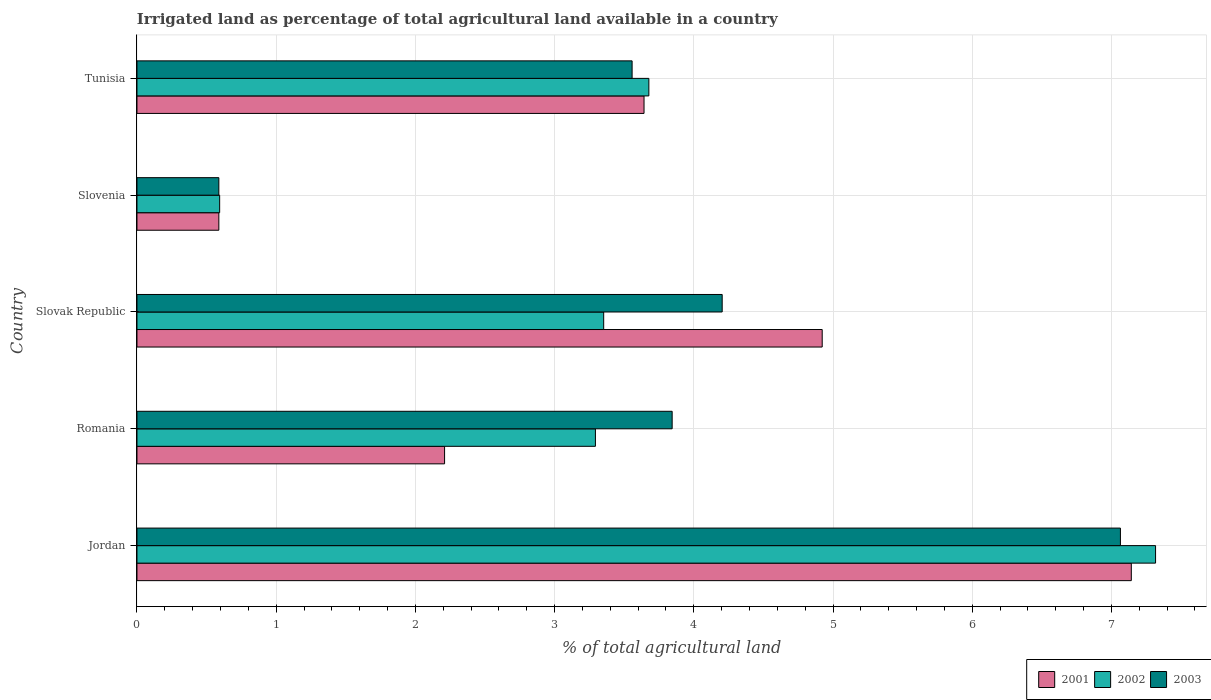Are the number of bars per tick equal to the number of legend labels?
Your answer should be compact. Yes. How many bars are there on the 5th tick from the bottom?
Provide a succinct answer. 3. What is the label of the 4th group of bars from the top?
Ensure brevity in your answer.  Romania. What is the percentage of irrigated land in 2002 in Jordan?
Provide a short and direct response. 7.32. Across all countries, what is the maximum percentage of irrigated land in 2002?
Offer a terse response. 7.32. Across all countries, what is the minimum percentage of irrigated land in 2003?
Keep it short and to the point. 0.59. In which country was the percentage of irrigated land in 2002 maximum?
Provide a succinct answer. Jordan. In which country was the percentage of irrigated land in 2003 minimum?
Keep it short and to the point. Slovenia. What is the total percentage of irrigated land in 2003 in the graph?
Your response must be concise. 19.26. What is the difference between the percentage of irrigated land in 2003 in Jordan and that in Slovenia?
Provide a short and direct response. 6.48. What is the difference between the percentage of irrigated land in 2002 in Romania and the percentage of irrigated land in 2001 in Tunisia?
Provide a succinct answer. -0.35. What is the average percentage of irrigated land in 2003 per country?
Your answer should be very brief. 3.85. What is the ratio of the percentage of irrigated land in 2003 in Jordan to that in Romania?
Make the answer very short. 1.84. Is the percentage of irrigated land in 2002 in Slovenia less than that in Tunisia?
Offer a very short reply. Yes. Is the difference between the percentage of irrigated land in 2001 in Slovak Republic and Tunisia greater than the difference between the percentage of irrigated land in 2003 in Slovak Republic and Tunisia?
Ensure brevity in your answer.  Yes. What is the difference between the highest and the second highest percentage of irrigated land in 2001?
Your response must be concise. 2.22. What is the difference between the highest and the lowest percentage of irrigated land in 2001?
Provide a succinct answer. 6.55. What does the 3rd bar from the top in Romania represents?
Keep it short and to the point. 2001. Is it the case that in every country, the sum of the percentage of irrigated land in 2003 and percentage of irrigated land in 2002 is greater than the percentage of irrigated land in 2001?
Keep it short and to the point. Yes. Are all the bars in the graph horizontal?
Your answer should be very brief. Yes. How many countries are there in the graph?
Ensure brevity in your answer.  5. What is the difference between two consecutive major ticks on the X-axis?
Make the answer very short. 1. Does the graph contain grids?
Give a very brief answer. Yes. Where does the legend appear in the graph?
Your answer should be very brief. Bottom right. How are the legend labels stacked?
Keep it short and to the point. Horizontal. What is the title of the graph?
Make the answer very short. Irrigated land as percentage of total agricultural land available in a country. What is the label or title of the X-axis?
Keep it short and to the point. % of total agricultural land. What is the label or title of the Y-axis?
Ensure brevity in your answer.  Country. What is the % of total agricultural land in 2001 in Jordan?
Your answer should be very brief. 7.14. What is the % of total agricultural land in 2002 in Jordan?
Make the answer very short. 7.32. What is the % of total agricultural land in 2003 in Jordan?
Provide a short and direct response. 7.06. What is the % of total agricultural land of 2001 in Romania?
Your answer should be very brief. 2.21. What is the % of total agricultural land in 2002 in Romania?
Your response must be concise. 3.29. What is the % of total agricultural land of 2003 in Romania?
Ensure brevity in your answer.  3.84. What is the % of total agricultural land in 2001 in Slovak Republic?
Provide a short and direct response. 4.92. What is the % of total agricultural land in 2002 in Slovak Republic?
Your answer should be compact. 3.35. What is the % of total agricultural land of 2003 in Slovak Republic?
Your answer should be very brief. 4.2. What is the % of total agricultural land of 2001 in Slovenia?
Give a very brief answer. 0.59. What is the % of total agricultural land of 2002 in Slovenia?
Your response must be concise. 0.59. What is the % of total agricultural land in 2003 in Slovenia?
Your answer should be compact. 0.59. What is the % of total agricultural land in 2001 in Tunisia?
Your answer should be compact. 3.64. What is the % of total agricultural land of 2002 in Tunisia?
Offer a terse response. 3.68. What is the % of total agricultural land of 2003 in Tunisia?
Your answer should be compact. 3.56. Across all countries, what is the maximum % of total agricultural land of 2001?
Provide a short and direct response. 7.14. Across all countries, what is the maximum % of total agricultural land in 2002?
Your answer should be compact. 7.32. Across all countries, what is the maximum % of total agricultural land of 2003?
Offer a terse response. 7.06. Across all countries, what is the minimum % of total agricultural land of 2001?
Your answer should be compact. 0.59. Across all countries, what is the minimum % of total agricultural land in 2002?
Make the answer very short. 0.59. Across all countries, what is the minimum % of total agricultural land of 2003?
Provide a succinct answer. 0.59. What is the total % of total agricultural land of 2001 in the graph?
Your answer should be compact. 18.51. What is the total % of total agricultural land in 2002 in the graph?
Give a very brief answer. 18.23. What is the total % of total agricultural land in 2003 in the graph?
Provide a short and direct response. 19.26. What is the difference between the % of total agricultural land in 2001 in Jordan and that in Romania?
Give a very brief answer. 4.93. What is the difference between the % of total agricultural land in 2002 in Jordan and that in Romania?
Provide a short and direct response. 4.02. What is the difference between the % of total agricultural land in 2003 in Jordan and that in Romania?
Your response must be concise. 3.22. What is the difference between the % of total agricultural land in 2001 in Jordan and that in Slovak Republic?
Keep it short and to the point. 2.22. What is the difference between the % of total agricultural land in 2002 in Jordan and that in Slovak Republic?
Give a very brief answer. 3.96. What is the difference between the % of total agricultural land in 2003 in Jordan and that in Slovak Republic?
Your answer should be compact. 2.86. What is the difference between the % of total agricultural land of 2001 in Jordan and that in Slovenia?
Ensure brevity in your answer.  6.55. What is the difference between the % of total agricultural land in 2002 in Jordan and that in Slovenia?
Your response must be concise. 6.72. What is the difference between the % of total agricultural land of 2003 in Jordan and that in Slovenia?
Keep it short and to the point. 6.48. What is the difference between the % of total agricultural land of 2001 in Jordan and that in Tunisia?
Make the answer very short. 3.5. What is the difference between the % of total agricultural land in 2002 in Jordan and that in Tunisia?
Keep it short and to the point. 3.64. What is the difference between the % of total agricultural land of 2003 in Jordan and that in Tunisia?
Provide a succinct answer. 3.51. What is the difference between the % of total agricultural land in 2001 in Romania and that in Slovak Republic?
Ensure brevity in your answer.  -2.71. What is the difference between the % of total agricultural land of 2002 in Romania and that in Slovak Republic?
Ensure brevity in your answer.  -0.06. What is the difference between the % of total agricultural land in 2003 in Romania and that in Slovak Republic?
Your response must be concise. -0.36. What is the difference between the % of total agricultural land of 2001 in Romania and that in Slovenia?
Offer a terse response. 1.62. What is the difference between the % of total agricultural land of 2002 in Romania and that in Slovenia?
Give a very brief answer. 2.7. What is the difference between the % of total agricultural land of 2003 in Romania and that in Slovenia?
Provide a short and direct response. 3.26. What is the difference between the % of total agricultural land in 2001 in Romania and that in Tunisia?
Keep it short and to the point. -1.43. What is the difference between the % of total agricultural land of 2002 in Romania and that in Tunisia?
Provide a short and direct response. -0.38. What is the difference between the % of total agricultural land in 2003 in Romania and that in Tunisia?
Offer a terse response. 0.29. What is the difference between the % of total agricultural land of 2001 in Slovak Republic and that in Slovenia?
Your response must be concise. 4.33. What is the difference between the % of total agricultural land in 2002 in Slovak Republic and that in Slovenia?
Offer a very short reply. 2.76. What is the difference between the % of total agricultural land in 2003 in Slovak Republic and that in Slovenia?
Provide a short and direct response. 3.62. What is the difference between the % of total agricultural land of 2001 in Slovak Republic and that in Tunisia?
Your response must be concise. 1.28. What is the difference between the % of total agricultural land in 2002 in Slovak Republic and that in Tunisia?
Offer a terse response. -0.32. What is the difference between the % of total agricultural land of 2003 in Slovak Republic and that in Tunisia?
Your answer should be very brief. 0.65. What is the difference between the % of total agricultural land in 2001 in Slovenia and that in Tunisia?
Make the answer very short. -3.05. What is the difference between the % of total agricultural land of 2002 in Slovenia and that in Tunisia?
Your answer should be compact. -3.08. What is the difference between the % of total agricultural land of 2003 in Slovenia and that in Tunisia?
Provide a succinct answer. -2.97. What is the difference between the % of total agricultural land in 2001 in Jordan and the % of total agricultural land in 2002 in Romania?
Make the answer very short. 3.85. What is the difference between the % of total agricultural land of 2001 in Jordan and the % of total agricultural land of 2003 in Romania?
Your answer should be compact. 3.3. What is the difference between the % of total agricultural land of 2002 in Jordan and the % of total agricultural land of 2003 in Romania?
Provide a short and direct response. 3.47. What is the difference between the % of total agricultural land of 2001 in Jordan and the % of total agricultural land of 2002 in Slovak Republic?
Your answer should be compact. 3.79. What is the difference between the % of total agricultural land of 2001 in Jordan and the % of total agricultural land of 2003 in Slovak Republic?
Give a very brief answer. 2.94. What is the difference between the % of total agricultural land in 2002 in Jordan and the % of total agricultural land in 2003 in Slovak Republic?
Offer a terse response. 3.11. What is the difference between the % of total agricultural land in 2001 in Jordan and the % of total agricultural land in 2002 in Slovenia?
Provide a short and direct response. 6.55. What is the difference between the % of total agricultural land in 2001 in Jordan and the % of total agricultural land in 2003 in Slovenia?
Your response must be concise. 6.55. What is the difference between the % of total agricultural land of 2002 in Jordan and the % of total agricultural land of 2003 in Slovenia?
Your answer should be very brief. 6.73. What is the difference between the % of total agricultural land of 2001 in Jordan and the % of total agricultural land of 2002 in Tunisia?
Your response must be concise. 3.47. What is the difference between the % of total agricultural land in 2001 in Jordan and the % of total agricultural land in 2003 in Tunisia?
Your answer should be very brief. 3.59. What is the difference between the % of total agricultural land of 2002 in Jordan and the % of total agricultural land of 2003 in Tunisia?
Offer a very short reply. 3.76. What is the difference between the % of total agricultural land of 2001 in Romania and the % of total agricultural land of 2002 in Slovak Republic?
Provide a succinct answer. -1.14. What is the difference between the % of total agricultural land in 2001 in Romania and the % of total agricultural land in 2003 in Slovak Republic?
Provide a short and direct response. -1.99. What is the difference between the % of total agricultural land in 2002 in Romania and the % of total agricultural land in 2003 in Slovak Republic?
Keep it short and to the point. -0.91. What is the difference between the % of total agricultural land in 2001 in Romania and the % of total agricultural land in 2002 in Slovenia?
Your answer should be very brief. 1.62. What is the difference between the % of total agricultural land of 2001 in Romania and the % of total agricultural land of 2003 in Slovenia?
Ensure brevity in your answer.  1.62. What is the difference between the % of total agricultural land in 2002 in Romania and the % of total agricultural land in 2003 in Slovenia?
Make the answer very short. 2.71. What is the difference between the % of total agricultural land of 2001 in Romania and the % of total agricultural land of 2002 in Tunisia?
Your answer should be very brief. -1.47. What is the difference between the % of total agricultural land in 2001 in Romania and the % of total agricultural land in 2003 in Tunisia?
Keep it short and to the point. -1.35. What is the difference between the % of total agricultural land of 2002 in Romania and the % of total agricultural land of 2003 in Tunisia?
Ensure brevity in your answer.  -0.26. What is the difference between the % of total agricultural land in 2001 in Slovak Republic and the % of total agricultural land in 2002 in Slovenia?
Make the answer very short. 4.33. What is the difference between the % of total agricultural land of 2001 in Slovak Republic and the % of total agricultural land of 2003 in Slovenia?
Give a very brief answer. 4.33. What is the difference between the % of total agricultural land of 2002 in Slovak Republic and the % of total agricultural land of 2003 in Slovenia?
Ensure brevity in your answer.  2.76. What is the difference between the % of total agricultural land in 2001 in Slovak Republic and the % of total agricultural land in 2002 in Tunisia?
Offer a terse response. 1.25. What is the difference between the % of total agricultural land in 2001 in Slovak Republic and the % of total agricultural land in 2003 in Tunisia?
Your answer should be very brief. 1.37. What is the difference between the % of total agricultural land in 2002 in Slovak Republic and the % of total agricultural land in 2003 in Tunisia?
Provide a short and direct response. -0.2. What is the difference between the % of total agricultural land in 2001 in Slovenia and the % of total agricultural land in 2002 in Tunisia?
Ensure brevity in your answer.  -3.09. What is the difference between the % of total agricultural land of 2001 in Slovenia and the % of total agricultural land of 2003 in Tunisia?
Provide a succinct answer. -2.97. What is the difference between the % of total agricultural land of 2002 in Slovenia and the % of total agricultural land of 2003 in Tunisia?
Provide a short and direct response. -2.96. What is the average % of total agricultural land of 2001 per country?
Give a very brief answer. 3.7. What is the average % of total agricultural land of 2002 per country?
Provide a short and direct response. 3.65. What is the average % of total agricultural land of 2003 per country?
Your answer should be very brief. 3.85. What is the difference between the % of total agricultural land in 2001 and % of total agricultural land in 2002 in Jordan?
Provide a short and direct response. -0.17. What is the difference between the % of total agricultural land in 2001 and % of total agricultural land in 2003 in Jordan?
Offer a terse response. 0.08. What is the difference between the % of total agricultural land of 2002 and % of total agricultural land of 2003 in Jordan?
Make the answer very short. 0.25. What is the difference between the % of total agricultural land in 2001 and % of total agricultural land in 2002 in Romania?
Give a very brief answer. -1.08. What is the difference between the % of total agricultural land in 2001 and % of total agricultural land in 2003 in Romania?
Your answer should be very brief. -1.63. What is the difference between the % of total agricultural land of 2002 and % of total agricultural land of 2003 in Romania?
Ensure brevity in your answer.  -0.55. What is the difference between the % of total agricultural land of 2001 and % of total agricultural land of 2002 in Slovak Republic?
Give a very brief answer. 1.57. What is the difference between the % of total agricultural land in 2001 and % of total agricultural land in 2003 in Slovak Republic?
Offer a terse response. 0.72. What is the difference between the % of total agricultural land of 2002 and % of total agricultural land of 2003 in Slovak Republic?
Give a very brief answer. -0.85. What is the difference between the % of total agricultural land in 2001 and % of total agricultural land in 2002 in Slovenia?
Offer a very short reply. -0.01. What is the difference between the % of total agricultural land of 2002 and % of total agricultural land of 2003 in Slovenia?
Offer a very short reply. 0.01. What is the difference between the % of total agricultural land in 2001 and % of total agricultural land in 2002 in Tunisia?
Offer a terse response. -0.03. What is the difference between the % of total agricultural land in 2001 and % of total agricultural land in 2003 in Tunisia?
Your response must be concise. 0.09. What is the difference between the % of total agricultural land in 2002 and % of total agricultural land in 2003 in Tunisia?
Your answer should be very brief. 0.12. What is the ratio of the % of total agricultural land of 2001 in Jordan to that in Romania?
Ensure brevity in your answer.  3.23. What is the ratio of the % of total agricultural land of 2002 in Jordan to that in Romania?
Provide a short and direct response. 2.22. What is the ratio of the % of total agricultural land in 2003 in Jordan to that in Romania?
Offer a very short reply. 1.84. What is the ratio of the % of total agricultural land of 2001 in Jordan to that in Slovak Republic?
Your response must be concise. 1.45. What is the ratio of the % of total agricultural land in 2002 in Jordan to that in Slovak Republic?
Offer a very short reply. 2.18. What is the ratio of the % of total agricultural land in 2003 in Jordan to that in Slovak Republic?
Your response must be concise. 1.68. What is the ratio of the % of total agricultural land in 2001 in Jordan to that in Slovenia?
Your response must be concise. 12.14. What is the ratio of the % of total agricultural land in 2002 in Jordan to that in Slovenia?
Your answer should be very brief. 12.32. What is the ratio of the % of total agricultural land of 2003 in Jordan to that in Slovenia?
Your answer should be compact. 12.01. What is the ratio of the % of total agricultural land in 2001 in Jordan to that in Tunisia?
Ensure brevity in your answer.  1.96. What is the ratio of the % of total agricultural land of 2002 in Jordan to that in Tunisia?
Ensure brevity in your answer.  1.99. What is the ratio of the % of total agricultural land of 2003 in Jordan to that in Tunisia?
Provide a succinct answer. 1.99. What is the ratio of the % of total agricultural land in 2001 in Romania to that in Slovak Republic?
Offer a very short reply. 0.45. What is the ratio of the % of total agricultural land in 2002 in Romania to that in Slovak Republic?
Keep it short and to the point. 0.98. What is the ratio of the % of total agricultural land of 2003 in Romania to that in Slovak Republic?
Offer a terse response. 0.91. What is the ratio of the % of total agricultural land in 2001 in Romania to that in Slovenia?
Make the answer very short. 3.76. What is the ratio of the % of total agricultural land in 2002 in Romania to that in Slovenia?
Make the answer very short. 5.54. What is the ratio of the % of total agricultural land in 2003 in Romania to that in Slovenia?
Offer a terse response. 6.54. What is the ratio of the % of total agricultural land in 2001 in Romania to that in Tunisia?
Give a very brief answer. 0.61. What is the ratio of the % of total agricultural land of 2002 in Romania to that in Tunisia?
Provide a succinct answer. 0.9. What is the ratio of the % of total agricultural land of 2003 in Romania to that in Tunisia?
Ensure brevity in your answer.  1.08. What is the ratio of the % of total agricultural land in 2001 in Slovak Republic to that in Slovenia?
Make the answer very short. 8.37. What is the ratio of the % of total agricultural land of 2002 in Slovak Republic to that in Slovenia?
Your answer should be very brief. 5.64. What is the ratio of the % of total agricultural land of 2003 in Slovak Republic to that in Slovenia?
Offer a terse response. 7.15. What is the ratio of the % of total agricultural land of 2001 in Slovak Republic to that in Tunisia?
Your answer should be very brief. 1.35. What is the ratio of the % of total agricultural land of 2002 in Slovak Republic to that in Tunisia?
Offer a terse response. 0.91. What is the ratio of the % of total agricultural land of 2003 in Slovak Republic to that in Tunisia?
Make the answer very short. 1.18. What is the ratio of the % of total agricultural land in 2001 in Slovenia to that in Tunisia?
Provide a short and direct response. 0.16. What is the ratio of the % of total agricultural land of 2002 in Slovenia to that in Tunisia?
Offer a very short reply. 0.16. What is the ratio of the % of total agricultural land of 2003 in Slovenia to that in Tunisia?
Give a very brief answer. 0.17. What is the difference between the highest and the second highest % of total agricultural land in 2001?
Provide a succinct answer. 2.22. What is the difference between the highest and the second highest % of total agricultural land in 2002?
Your answer should be compact. 3.64. What is the difference between the highest and the second highest % of total agricultural land of 2003?
Provide a succinct answer. 2.86. What is the difference between the highest and the lowest % of total agricultural land in 2001?
Keep it short and to the point. 6.55. What is the difference between the highest and the lowest % of total agricultural land of 2002?
Keep it short and to the point. 6.72. What is the difference between the highest and the lowest % of total agricultural land of 2003?
Your response must be concise. 6.48. 